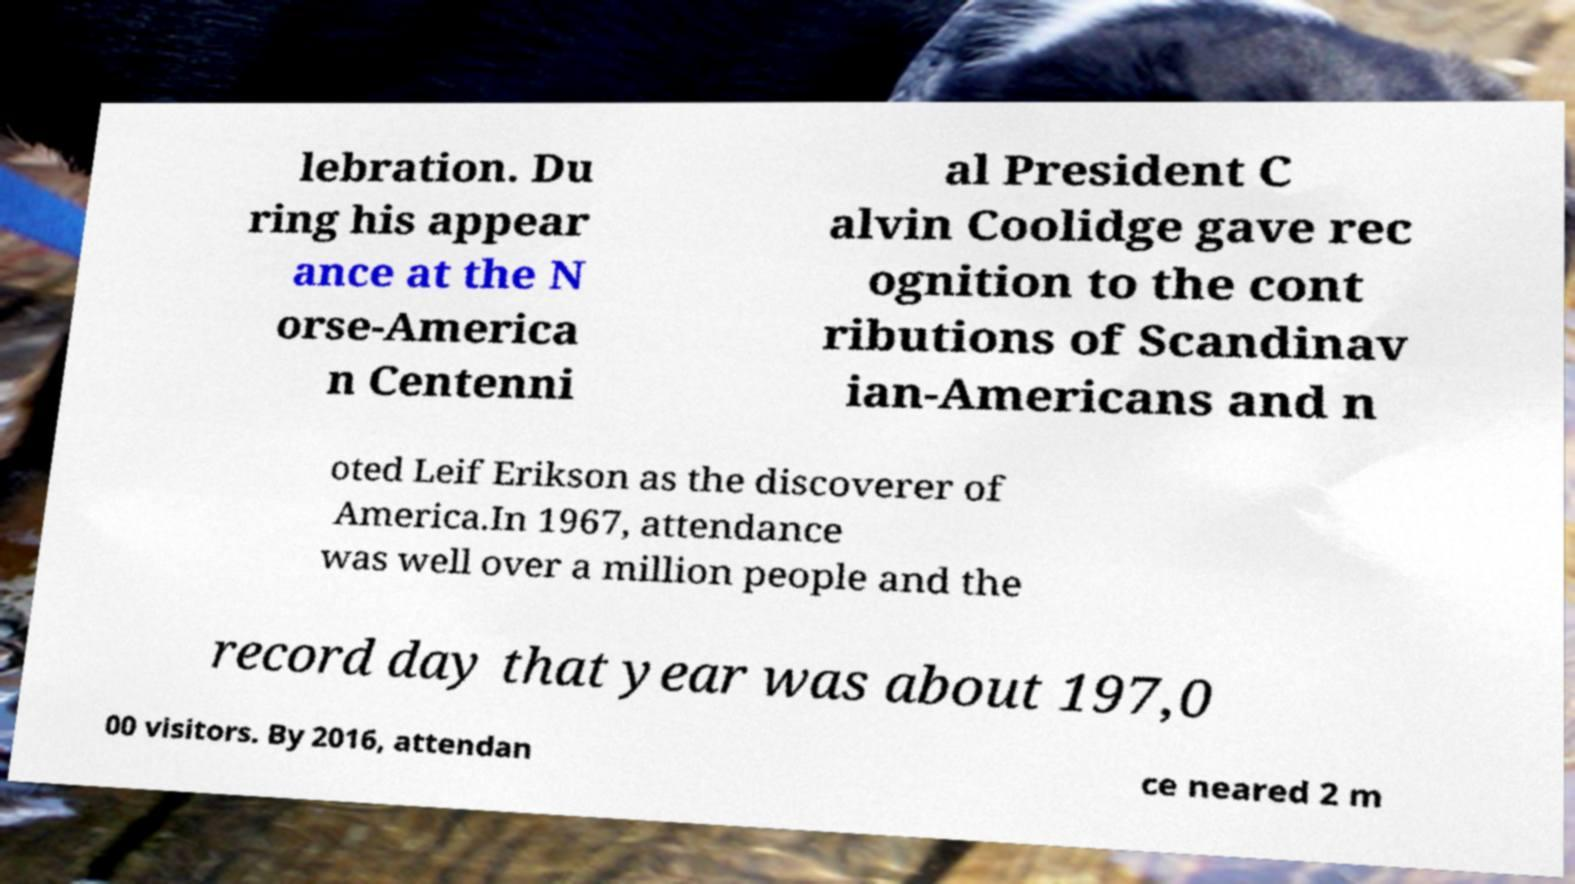What messages or text are displayed in this image? I need them in a readable, typed format. lebration. Du ring his appear ance at the N orse-America n Centenni al President C alvin Coolidge gave rec ognition to the cont ributions of Scandinav ian-Americans and n oted Leif Erikson as the discoverer of America.In 1967, attendance was well over a million people and the record day that year was about 197,0 00 visitors. By 2016, attendan ce neared 2 m 